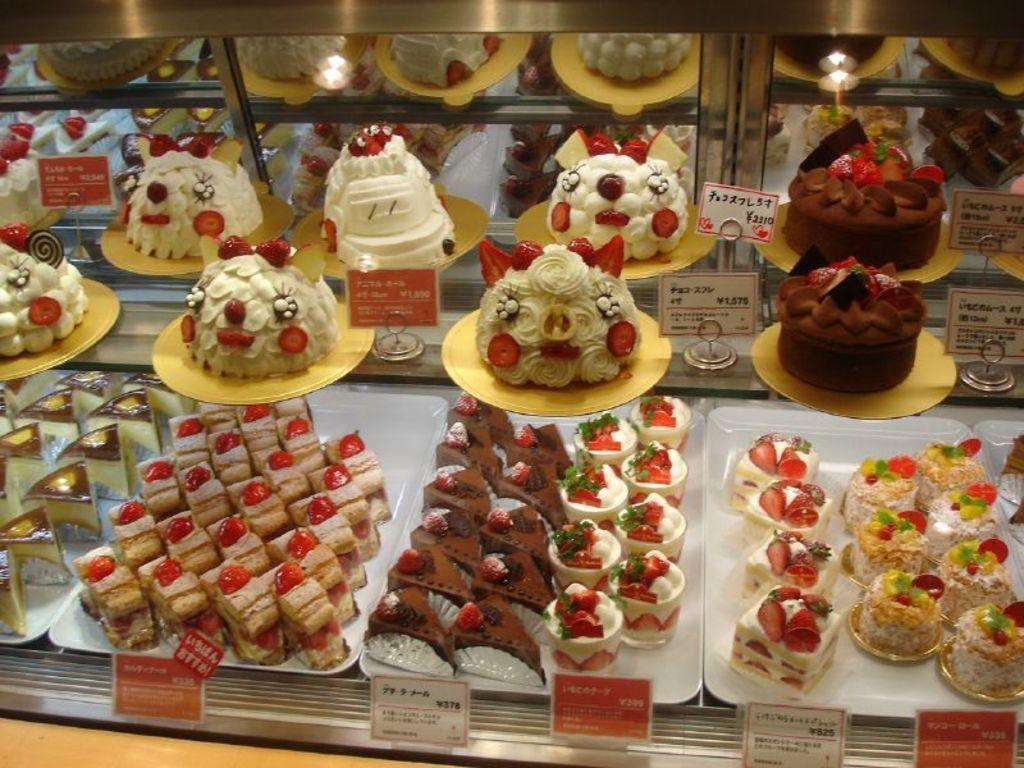What type of food items can be seen in the image? There are cakes and pastries in the image. How are the cakes and pastries arranged in the image? The cakes and pastries are displayed in the image. How can one determine the price of each item? Each item has a price tag in front of it. What type of patch can be seen on the pot in the image? There is no patch or pot present in the image; it only features cakes and pastries with price tags. 